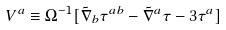<formula> <loc_0><loc_0><loc_500><loc_500>V ^ { a } \equiv \Omega ^ { - 1 } [ \tilde { \nabla } _ { b } \tau ^ { a b } - \tilde { \nabla } ^ { a } \tau - 3 \tau ^ { a } ]</formula> 